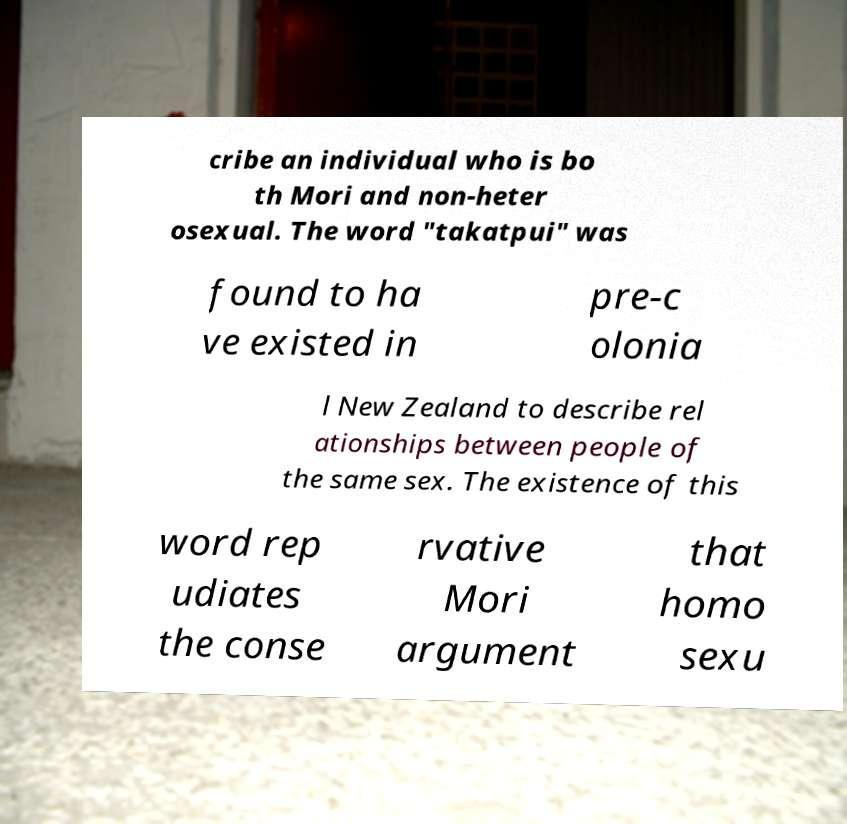Please identify and transcribe the text found in this image. cribe an individual who is bo th Mori and non-heter osexual. The word "takatpui" was found to ha ve existed in pre-c olonia l New Zealand to describe rel ationships between people of the same sex. The existence of this word rep udiates the conse rvative Mori argument that homo sexu 